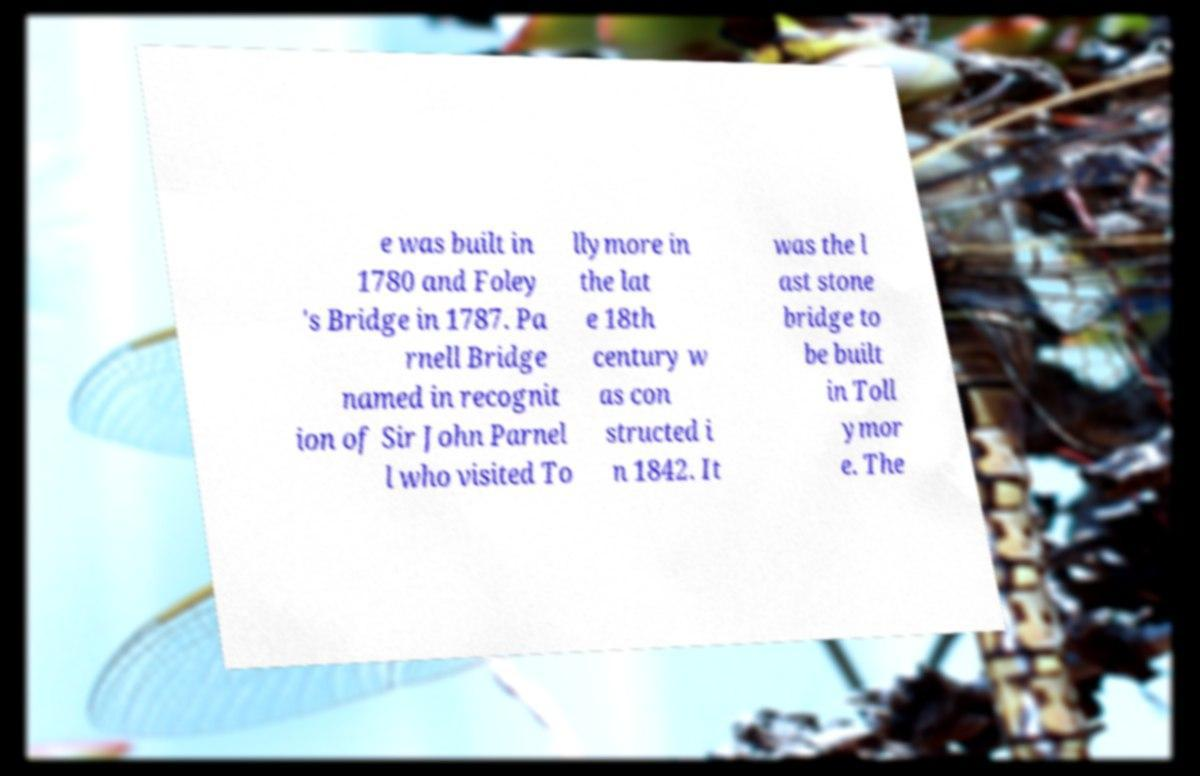Can you read and provide the text displayed in the image?This photo seems to have some interesting text. Can you extract and type it out for me? e was built in 1780 and Foley 's Bridge in 1787. Pa rnell Bridge named in recognit ion of Sir John Parnel l who visited To llymore in the lat e 18th century w as con structed i n 1842. It was the l ast stone bridge to be built in Toll ymor e. The 